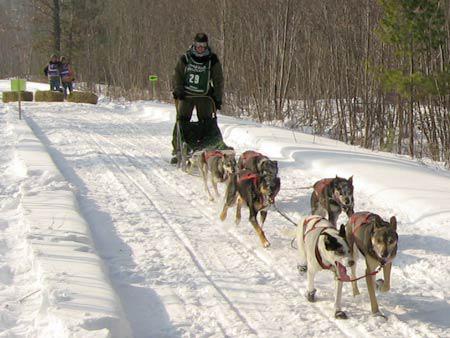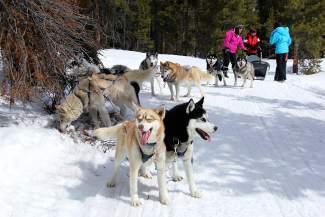The first image is the image on the left, the second image is the image on the right. For the images displayed, is the sentence "All of the dogs are running in snow." factually correct? Answer yes or no. No. The first image is the image on the left, the second image is the image on the right. For the images displayed, is the sentence "In the left image, two dogs are pulling a sled on the snow with a rope extending to the left." factually correct? Answer yes or no. No. 